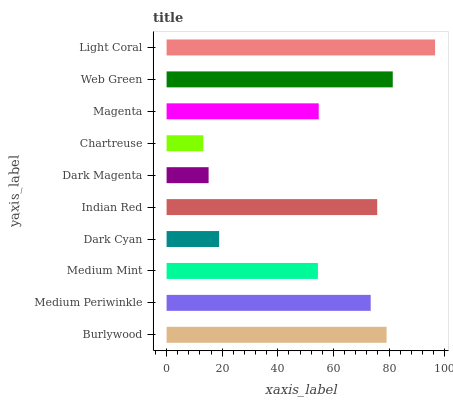Is Chartreuse the minimum?
Answer yes or no. Yes. Is Light Coral the maximum?
Answer yes or no. Yes. Is Medium Periwinkle the minimum?
Answer yes or no. No. Is Medium Periwinkle the maximum?
Answer yes or no. No. Is Burlywood greater than Medium Periwinkle?
Answer yes or no. Yes. Is Medium Periwinkle less than Burlywood?
Answer yes or no. Yes. Is Medium Periwinkle greater than Burlywood?
Answer yes or no. No. Is Burlywood less than Medium Periwinkle?
Answer yes or no. No. Is Medium Periwinkle the high median?
Answer yes or no. Yes. Is Magenta the low median?
Answer yes or no. Yes. Is Chartreuse the high median?
Answer yes or no. No. Is Chartreuse the low median?
Answer yes or no. No. 